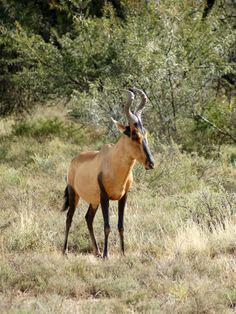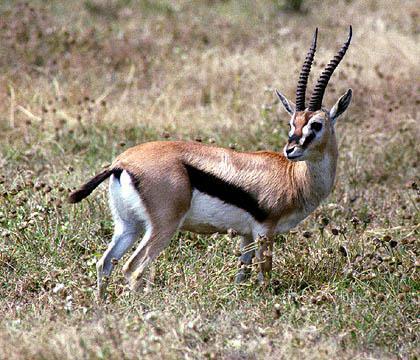The first image is the image on the left, the second image is the image on the right. Considering the images on both sides, is "The right hand image contains an animal facing left." valid? Answer yes or no. No. 